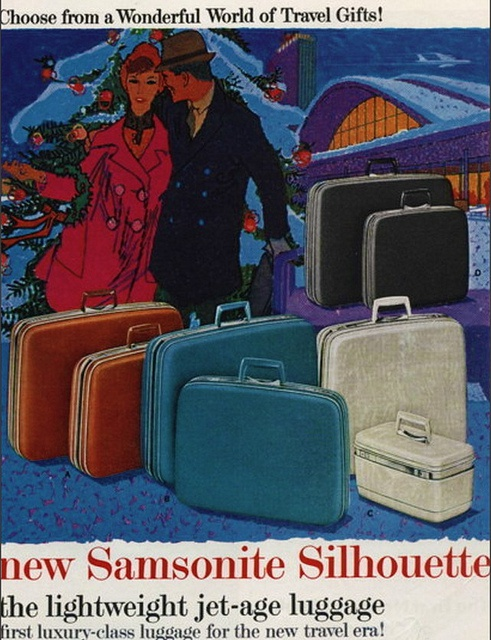Describe the objects in this image and their specific colors. I can see people in black, brown, maroon, and blue tones, suitcase in black, blue, darkblue, and teal tones, people in black, maroon, and blue tones, suitcase in black, darkgray, and gray tones, and suitcase in black, blue, darkblue, and teal tones in this image. 